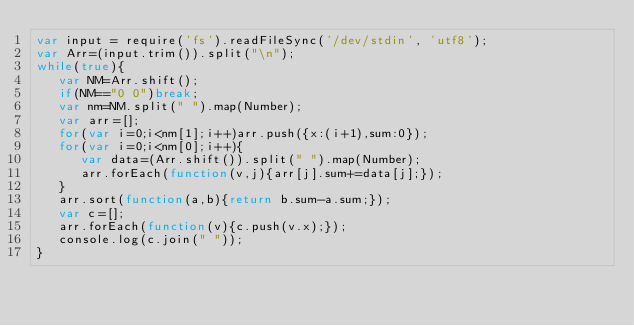<code> <loc_0><loc_0><loc_500><loc_500><_JavaScript_>var input = require('fs').readFileSync('/dev/stdin', 'utf8');
var Arr=(input.trim()).split("\n");
while(true){
   var NM=Arr.shift();
   if(NM=="0 0")break;
   var nm=NM.split(" ").map(Number);
   var arr=[];
   for(var i=0;i<nm[1];i++)arr.push({x:(i+1),sum:0});
   for(var i=0;i<nm[0];i++){
      var data=(Arr.shift()).split(" ").map(Number);
      arr.forEach(function(v,j){arr[j].sum+=data[j];});
   }
   arr.sort(function(a,b){return b.sum-a.sum;});
   var c=[];
   arr.forEach(function(v){c.push(v.x);});
   console.log(c.join(" "));
}</code> 